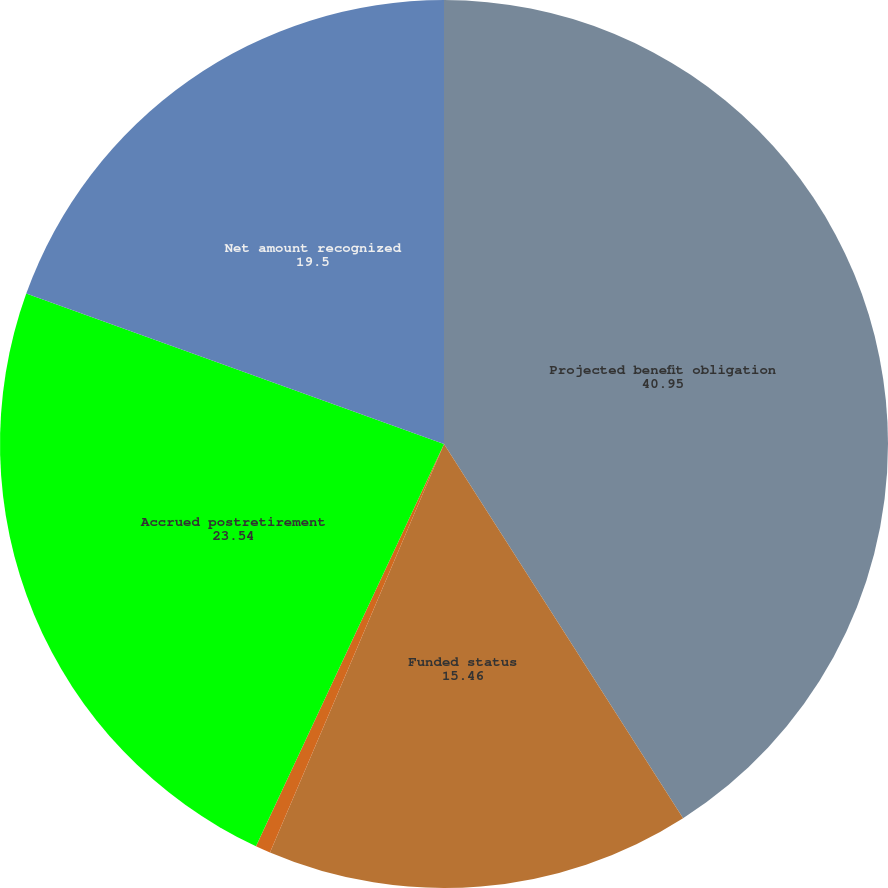<chart> <loc_0><loc_0><loc_500><loc_500><pie_chart><fcel>Projected benefit obligation<fcel>Funded status<fcel>Accrued and other current<fcel>Accrued postretirement<fcel>Net amount recognized<nl><fcel>40.95%<fcel>15.46%<fcel>0.55%<fcel>23.54%<fcel>19.5%<nl></chart> 